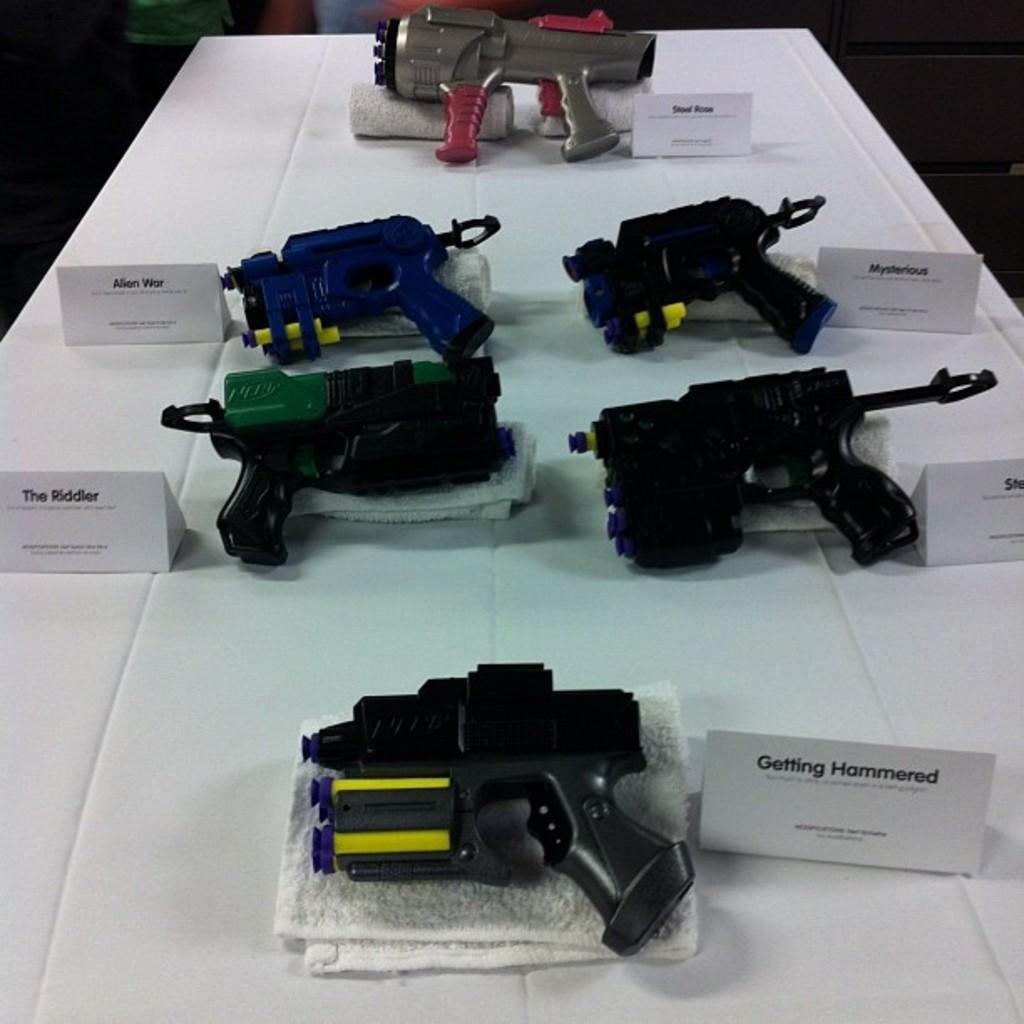What types of objects are present in the image? There are different types of guns in the image. What is the color of the surface on which the guns are placed? The guns are on a white surface. What material is the white surface made of? The white surface is a cloth. What else can be seen in the image besides the guns and the white cloth? There is a white paper with writing in the image. What type of scent can be detected from the guns in the image? There is no mention of a scent in the image, and it is not possible to detect a scent from a photograph. 